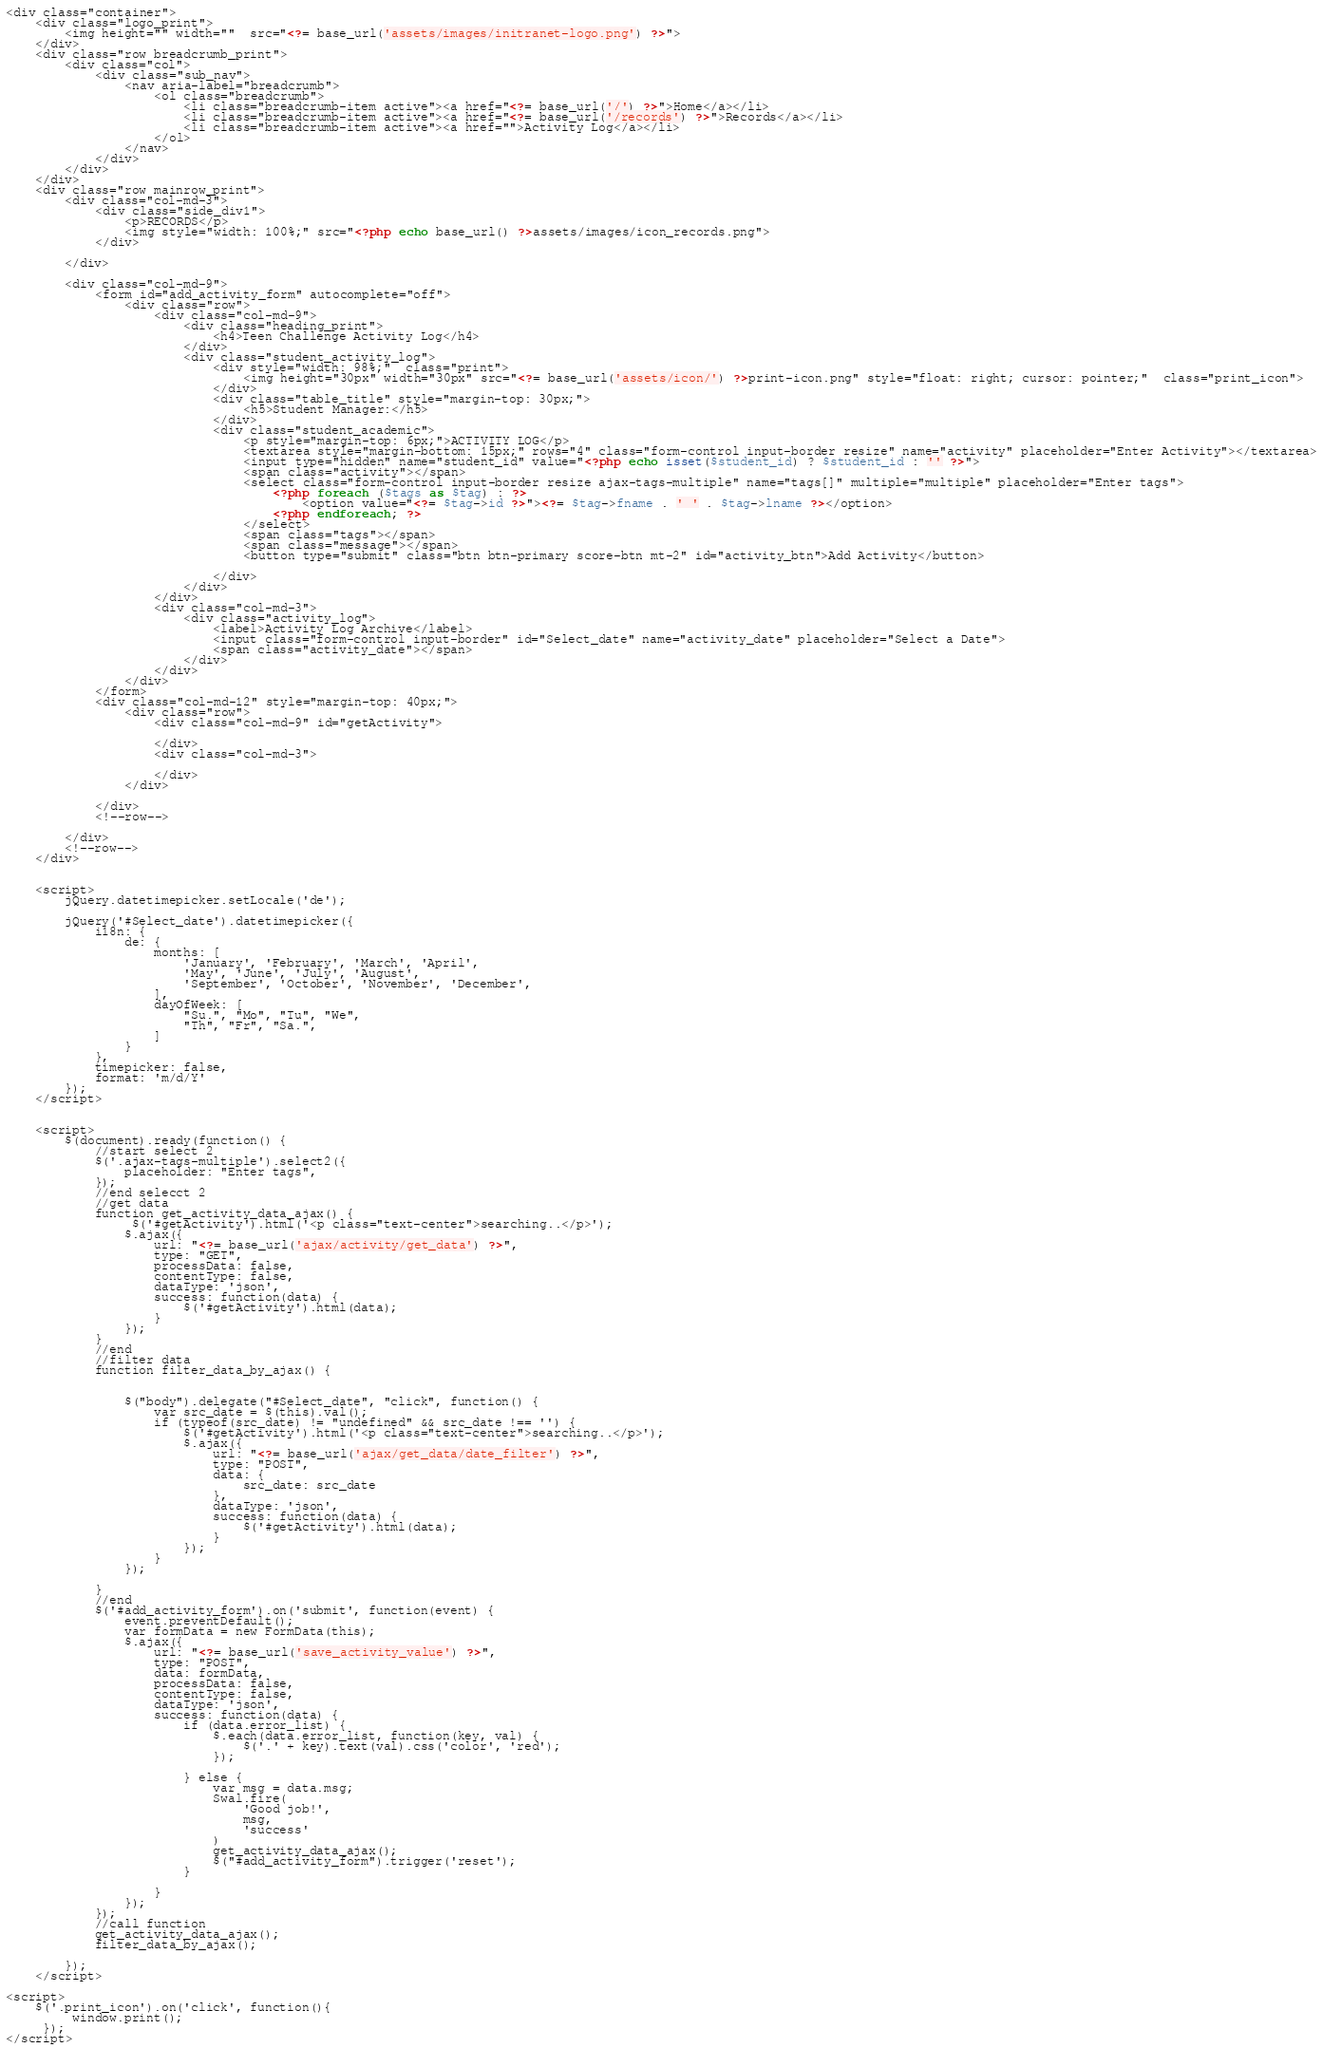<code> <loc_0><loc_0><loc_500><loc_500><_PHP_><div class="container">
	<div class="logo_print">
        <img height="" width=""  src="<?= base_url('assets/images/initranet-logo.png') ?>">
    </div>
	<div class="row breadcrumb_print">
		<div class="col">
			<div class="sub_nav">
				<nav aria-label="breadcrumb">
					<ol class="breadcrumb">
						<li class="breadcrumb-item active"><a href="<?= base_url('/') ?>">Home</a></li>
						<li class="breadcrumb-item active"><a href="<?= base_url('/records') ?>">Records</a></li>
						<li class="breadcrumb-item active"><a href="">Activity Log</a></li>
					</ol>
				</nav>
			</div>
		</div>
	</div>
	<div class="row mainrow_print">
		<div class="col-md-3">
			<div class="side_div1">
				<p>RECORDS</p>
				<img style="width: 100%;" src="<?php echo base_url() ?>assets/images/icon_records.png">
			</div>

		</div>

		<div class="col-md-9">
			<form id="add_activity_form" autocomplete="off">
				<div class="row">
					<div class="col-md-9">
						<div class="heading_print">
		                    <h4>Teen Challenge Activity Log</h4>
		                </div>
						<div class="student_activity_log">
			                <div style="width: 98%;"  class="print">
			                    <img height="30px" width="30px" src="<?= base_url('assets/icon/') ?>print-icon.png" style="float: right; cursor: pointer;"  class="print_icon">
			                </div>
							<div class="table_title" style="margin-top: 30px;">
								<h5>Student Manager:</h5>
							</div>
							<div class="student_academic">
								<p style="margin-top: 6px;">ACTIVITY LOG</p>
								<textarea style="margin-bottom: 15px;" rows="4" class="form-control input-border resize" name="activity" placeholder="Enter Activity"></textarea>
								<input type="hidden" name="student_id" value="<?php echo isset($student_id) ? $student_id : '' ?>">
								<span class="activity"></span>
								<select class="form-control input-border resize ajax-tags-multiple" name="tags[]" multiple="multiple" placeholder="Enter tags">
									<?php foreach ($tags as $tag) : ?>
										<option value="<?= $tag->id ?>"><?= $tag->fname . ' ' . $tag->lname ?></option>
									<?php endforeach; ?>
								</select>
								<span class="tags"></span>
								<span class="message"></span>
								<button type="submit" class="btn btn-primary score-btn mt-2" id="activity_btn">Add Activity</button>

							</div>
						</div>
					</div>
					<div class="col-md-3">
						<div class="activity_log">
							<label>Activity Log Archive</label>
							<input class="form-control input-border" id="Select_date" name="activity_date" placeholder="Select a Date">
							<span class="activity_date"></span>
						</div>
					</div>
				</div>
			</form>
			<div class="col-md-12" style="margin-top: 40px;">
				<div class="row">
					<div class="col-md-9" id="getActivity">

					</div>
					<div class="col-md-3">

					</div>
				</div>

			</div>
			<!--row-->

		</div>
		<!--row-->
	</div>


	<script>
		jQuery.datetimepicker.setLocale('de');

		jQuery('#Select_date').datetimepicker({
			i18n: {
				de: {
					months: [
						'January', 'February', 'March', 'April',
						'May', 'June', 'July', 'August',
						'September', 'October', 'November', 'December',
					],
					dayOfWeek: [
						"Su.", "Mo", "Tu", "We",
						"Th", "Fr", "Sa.",
					]
				}
			},
			timepicker: false,
			format: 'm/d/Y'
		});
	</script>


	<script>
		$(document).ready(function() {
			//start select 2
			$('.ajax-tags-multiple').select2({
				placeholder: "Enter tags",
			});
			//end selecct 2
			//get data
			function get_activity_data_ajax() {
                 $('#getActivity').html('<p class="text-center">searching..</p>');
				$.ajax({
					url: "<?= base_url('ajax/activity/get_data') ?>",
					type: "GET",
					processData: false,
					contentType: false,
					dataType: 'json',
					success: function(data) {
						$('#getActivity').html(data);
					}
				});
			}
			//end
			//filter data
			function filter_data_by_ajax() {


				$("body").delegate("#Select_date", "click", function() {
					var src_date = $(this).val();
					if (typeof(src_date) != "undefined" && src_date !== '') {
                        $('#getActivity').html('<p class="text-center">searching..</p>');
						$.ajax({
							url: "<?= base_url('ajax/get_data/date_filter') ?>",
							type: "POST",
							data: {
								src_date: src_date
							},
							dataType: 'json',
							success: function(data) {
								$('#getActivity').html(data);
							}
						});
					}
				});

			}
			//end
			$('#add_activity_form').on('submit', function(event) {
				event.preventDefault();
				var formData = new FormData(this);
				$.ajax({
					url: "<?= base_url('save_activity_value') ?>",
					type: "POST",
					data: formData,
					processData: false,
					contentType: false,
					dataType: 'json',
					success: function(data) {
						if (data.error_list) {
							$.each(data.error_list, function(key, val) {
								$('.' + key).text(val).css('color', 'red');
							});

						} else {
							var msg = data.msg;
							Swal.fire(
								'Good job!',
								msg,
								'success'
							)
							get_activity_data_ajax();
							$("#add_activity_form").trigger('reset');
						}

					}
				});
			});
			//call function          
			get_activity_data_ajax();
			filter_data_by_ajax();

		});
	</script>

<script>
    $('.print_icon').on('click', function(){
         window.print();
     });
</script></code> 